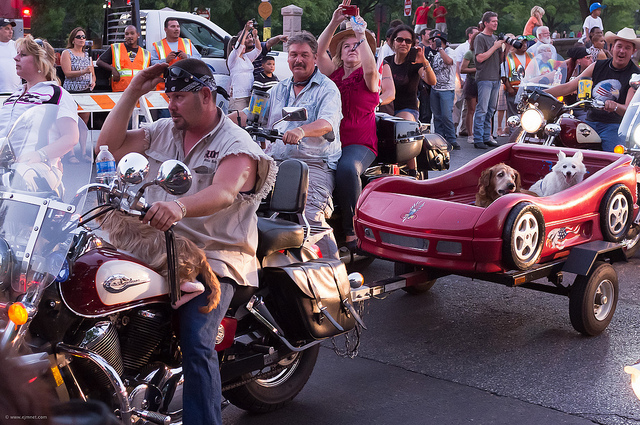<image>What type of motorcycle is at the head of the parade? I am not sure what type of motorcycle is at the head of parade. It could be a 'Honda', 'Harley Davidson', or 'Cobra'. What type of motorcycle is at the head of the parade? I don't know what type of motorcycle is at the head of the parade. It can be either a Honda, Harley Davidson, Cobra or a Red Harley. 